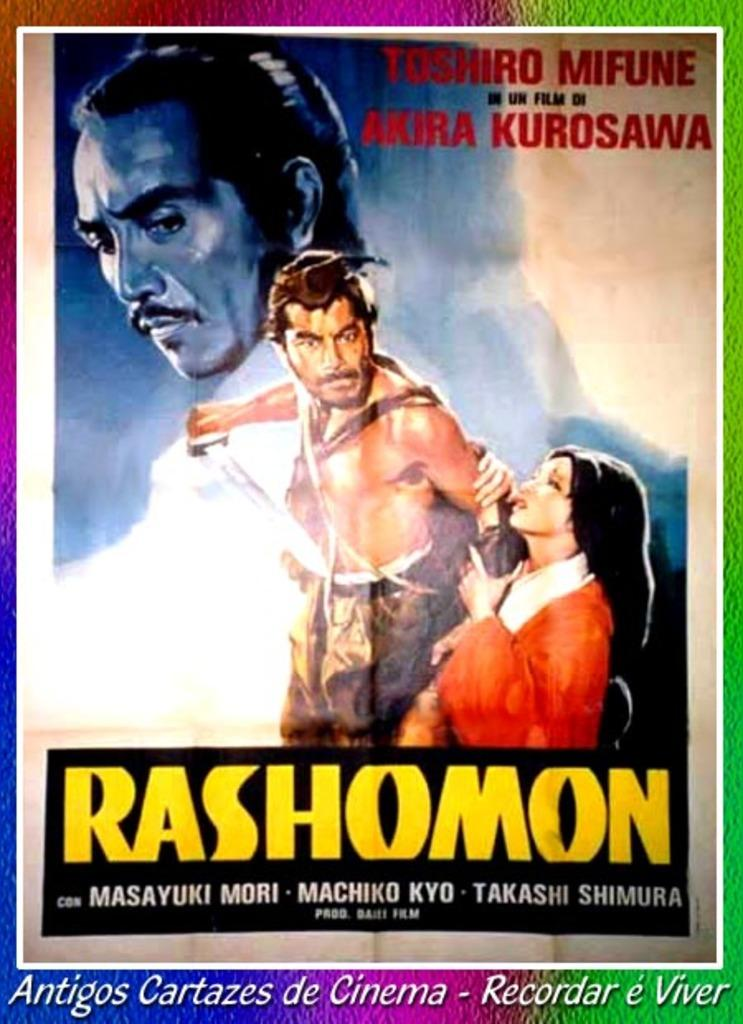<image>
Share a concise interpretation of the image provided. A poster for a movie titled Rashomon with actors such as Masayuki Mori. 